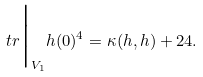<formula> <loc_0><loc_0><loc_500><loc_500>\ t r \Big | _ { V _ { 1 } } h ( 0 ) ^ { 4 } = \kappa ( h , h ) + 2 4 .</formula> 